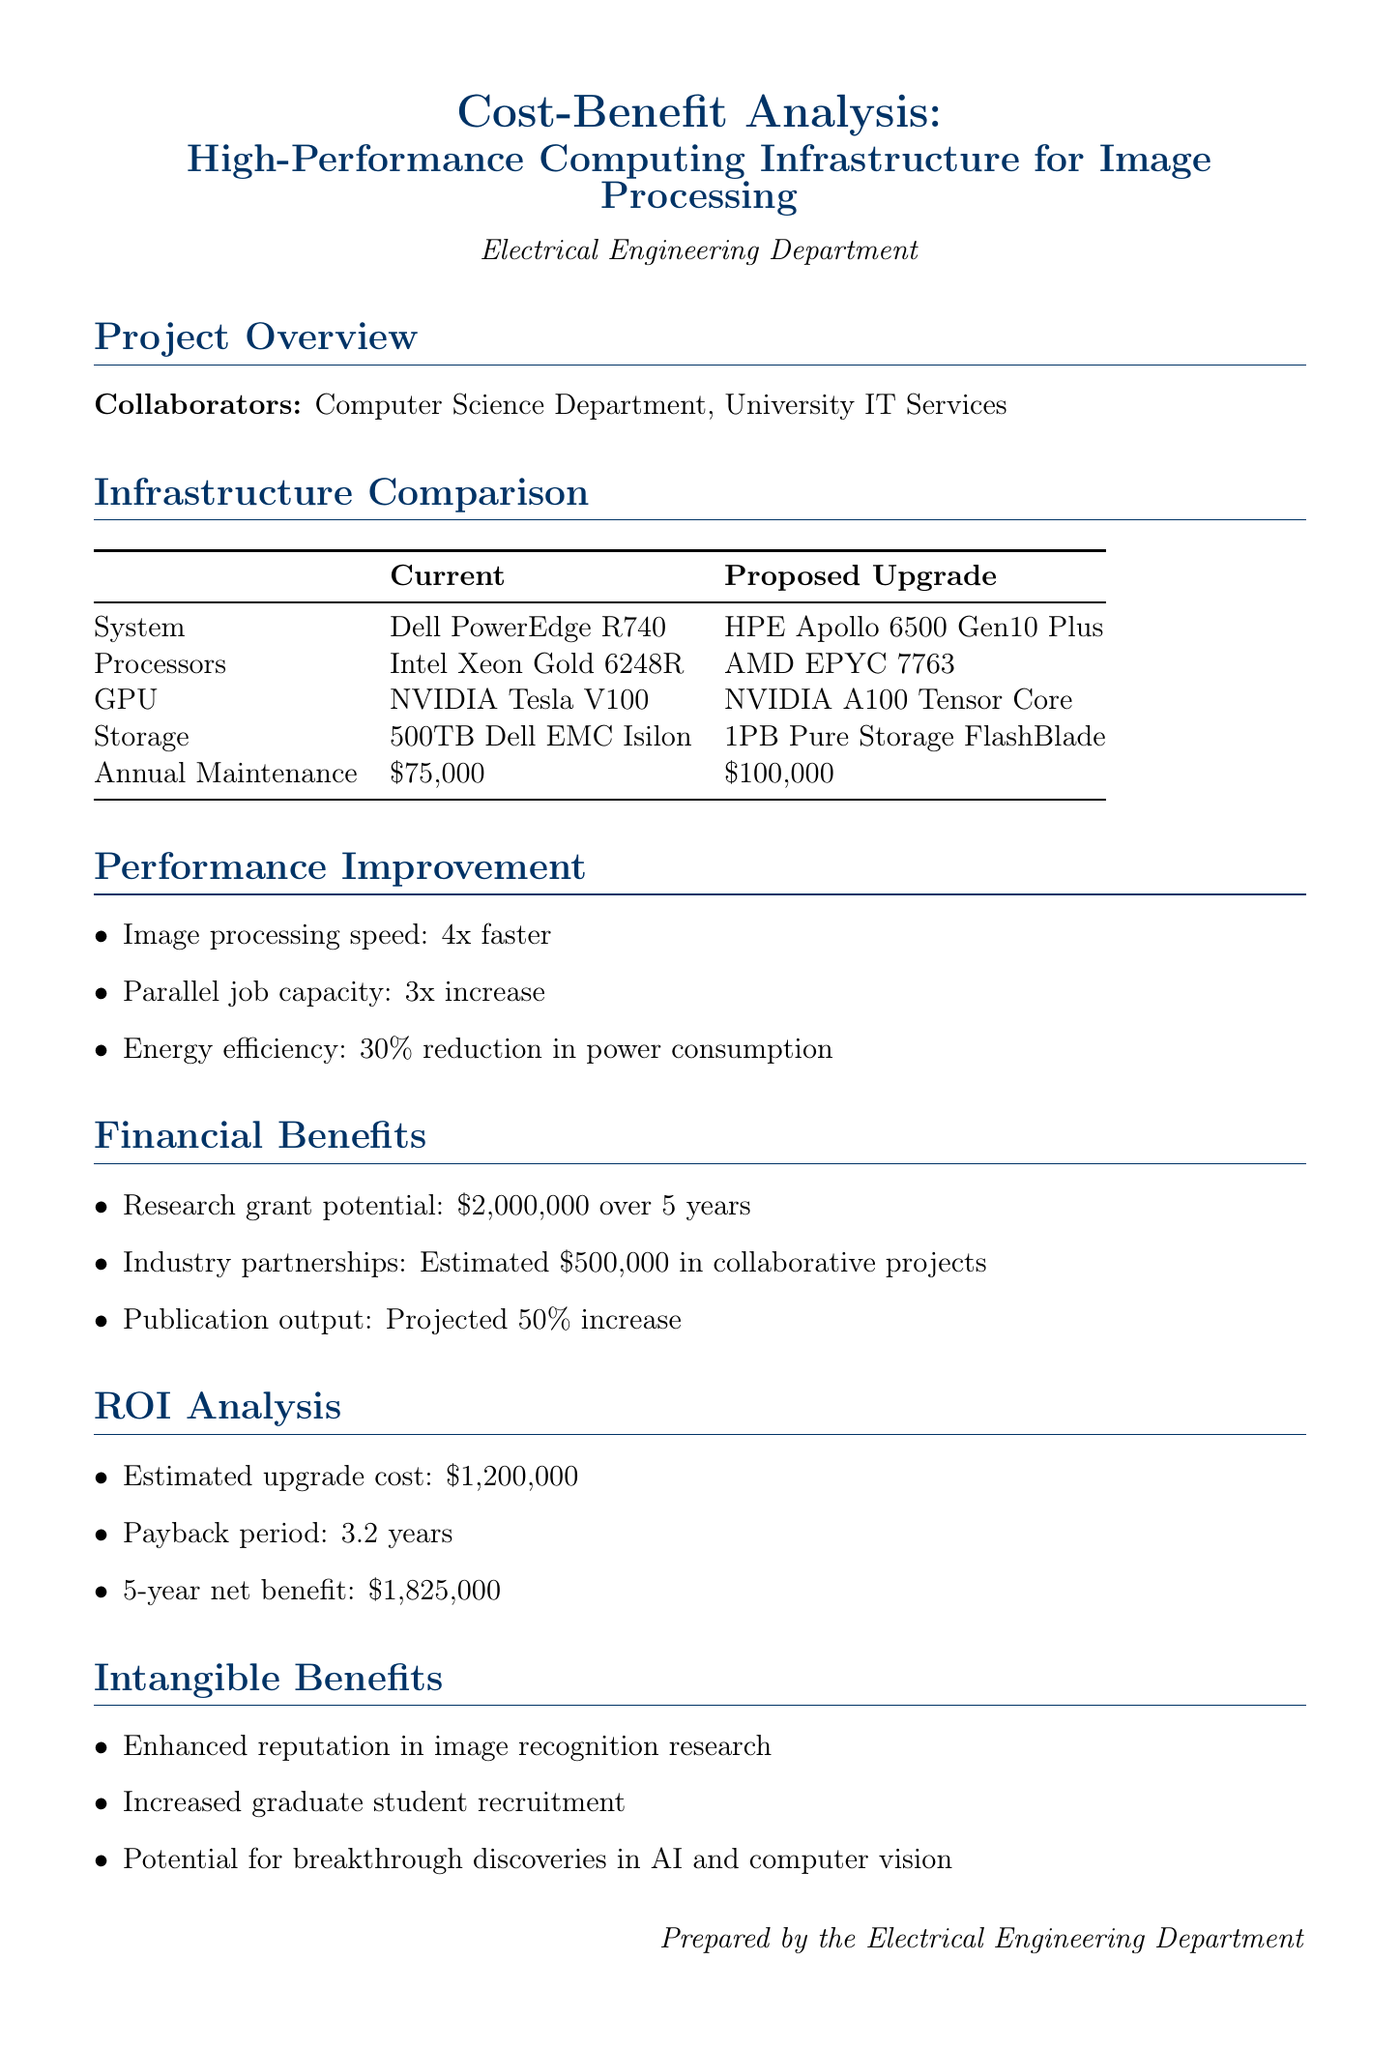What is the title of the project? The title is specified in the project overview section, which reads "Cost-Benefit Analysis: High-Performance Computing Infrastructure for Image Processing."
Answer: Cost-Benefit Analysis: High-Performance Computing Infrastructure for Image Processing Who are the collaborators mentioned? The collaborators are listed in the project overview section as the Computer Science Department and University IT Services.
Answer: Computer Science Department, University IT Services What is the estimated cost of the proposed upgrade? The estimated cost is explicitly stated in the proposed upgrade section of the document, which is $1,200,000.
Answer: $1,200,000 How much faster is the image processing speed with the proposed upgrade? The performance improvement section states the image processing speed will be 4 times faster with the upgrade.
Answer: 4x faster What is the projected payback period? The payback period is stated in the ROI analysis section, indicating the duration it will take to recoup the investment, which is 3.2 years.
Answer: 3.2 years What is the expected 5-year net benefit? The 5-year net benefit is outlined in the ROI analysis section, which quantifies the financial gain from the investment as $1,825,000.
Answer: $1,825,000 What percentage increase in publication output is projected? The financial benefits section specifies that a 50% increase in publication output is projected from the proposed upgrade.
Answer: 50% increase Which system is the current infrastructure based on? The current infrastructure system is identified in the infrastructure comparison table under current system details as Dell PowerEdge R740.
Answer: Dell PowerEdge R740 What intangible benefit is noted regarding graduate student recruitment? The intangible benefits section lists "Increased graduate student recruitment" as one of the potential benefits of the investment.
Answer: Increased graduate student recruitment 